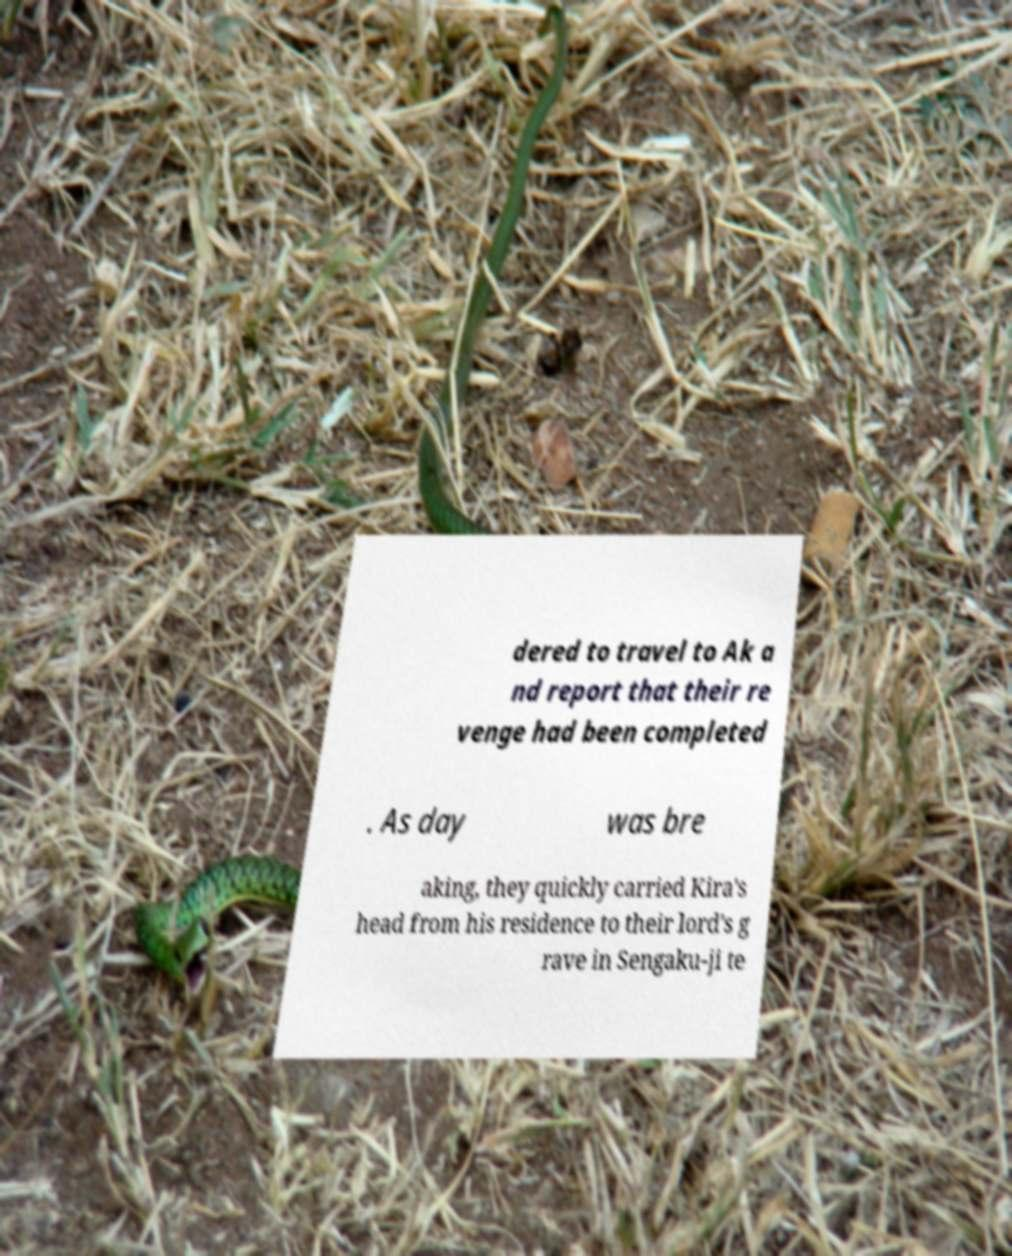Can you read and provide the text displayed in the image?This photo seems to have some interesting text. Can you extract and type it out for me? dered to travel to Ak a nd report that their re venge had been completed . As day was bre aking, they quickly carried Kira's head from his residence to their lord's g rave in Sengaku-ji te 